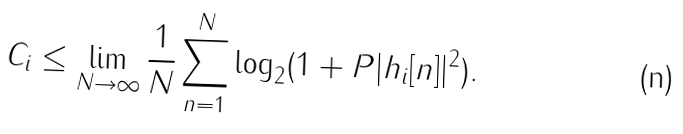Convert formula to latex. <formula><loc_0><loc_0><loc_500><loc_500>C _ { i } \leq \lim _ { N \rightarrow \infty } \frac { 1 } { N } \sum _ { n = 1 } ^ { N } \log _ { 2 } ( 1 + P | h _ { i } [ n ] | ^ { 2 } ) .</formula> 